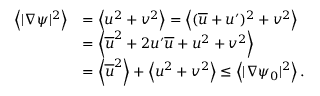<formula> <loc_0><loc_0><loc_500><loc_500>\begin{array} { r l } { \left < | \nabla \psi | ^ { 2 } \right > } & { = \left < u ^ { 2 } + v ^ { 2 } \right > = \left < ( \overline { u } + u ^ { \prime } ) ^ { 2 } + v ^ { 2 } \right > } \\ & { = \left < \overline { u } ^ { 2 } + 2 u ^ { \prime } \overline { u } + u ^ { 2 } + v ^ { 2 } \right > } \\ & { = \left < \overline { u } ^ { 2 } \right > + \left < u ^ { 2 } + v ^ { 2 } \right > \leq \left < | \nabla \psi _ { 0 } | ^ { 2 } \right > . } \end{array}</formula> 